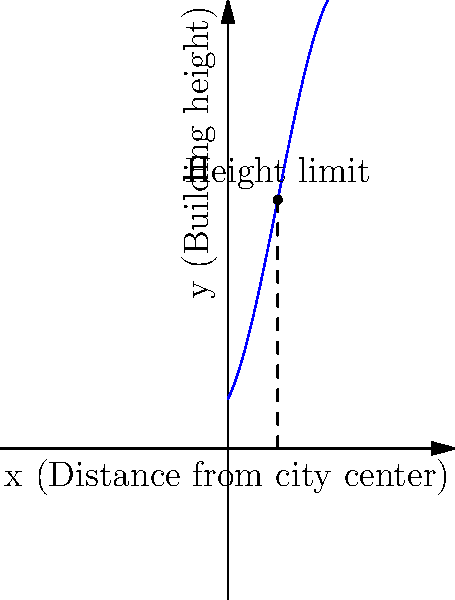As an urban planner in Buenos Aires, you're working on a revitalization project that involves designing a new skyline. The city has implemented a building height restriction based on the distance from the city center, modeled by the polynomial function $f(x) = -0.01x^3 + 0.3x^2 + 2x + 10$, where $x$ is the distance from the center in kilometers and $f(x)$ is the maximum allowed height in meters. What is the maximum allowed building height at a distance of 10 km from the city center? To find the maximum allowed building height at a distance of 10 km from the city center, we need to evaluate the given function $f(x)$ at $x = 10$. Let's follow these steps:

1. We have the function $f(x) = -0.01x^3 + 0.3x^2 + 2x + 10$
2. We need to calculate $f(10)$
3. Substitute $x = 10$ into the function:
   $f(10) = -0.01(10)^3 + 0.3(10)^2 + 2(10) + 10$
4. Evaluate each term:
   $f(10) = -0.01(1000) + 0.3(100) + 20 + 10$
5. Simplify:
   $f(10) = -10 + 30 + 20 + 10$
6. Sum up the terms:
   $f(10) = 50$

Therefore, the maximum allowed building height at a distance of 10 km from the city center is 50 meters.
Answer: 50 meters 